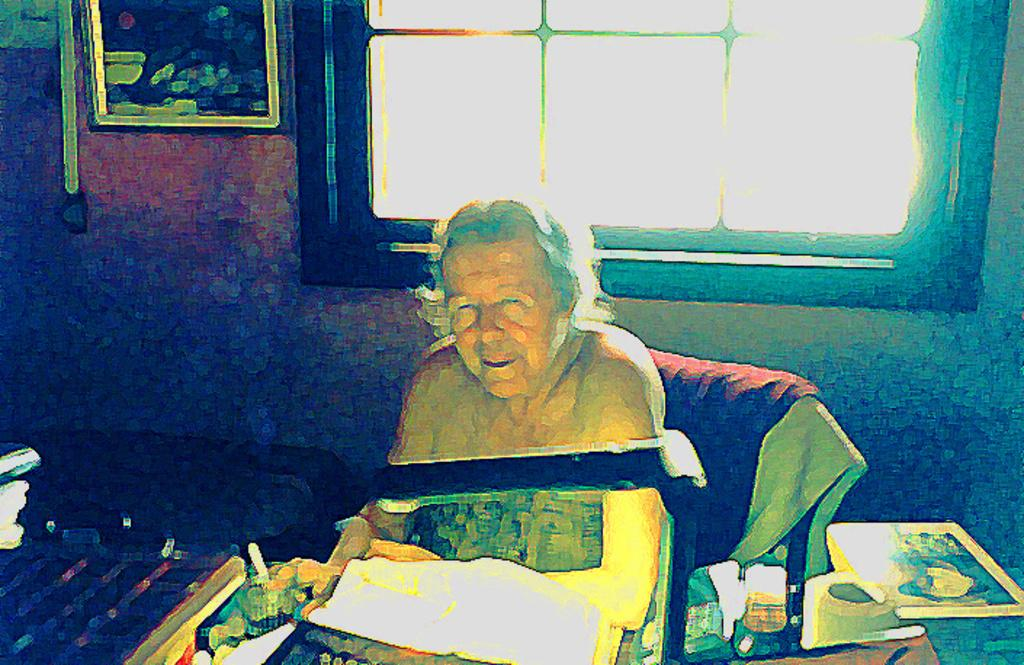What is the woman in the image doing? The woman is seated on a chair in the image. What is positioned in front of the woman? There is a light in front of the woman. What can be found on the table in front of the woman? There are other things on the table in front of the woman. What is visible on the wall in the background of the image? There is a frame on the wall in the background of the image. What type of hen can be seen in the image? There is no hen present in the image. Is the woman reading a paper in the image? The provided facts do not mention a paper, so it cannot be determined if the woman is reading one. 